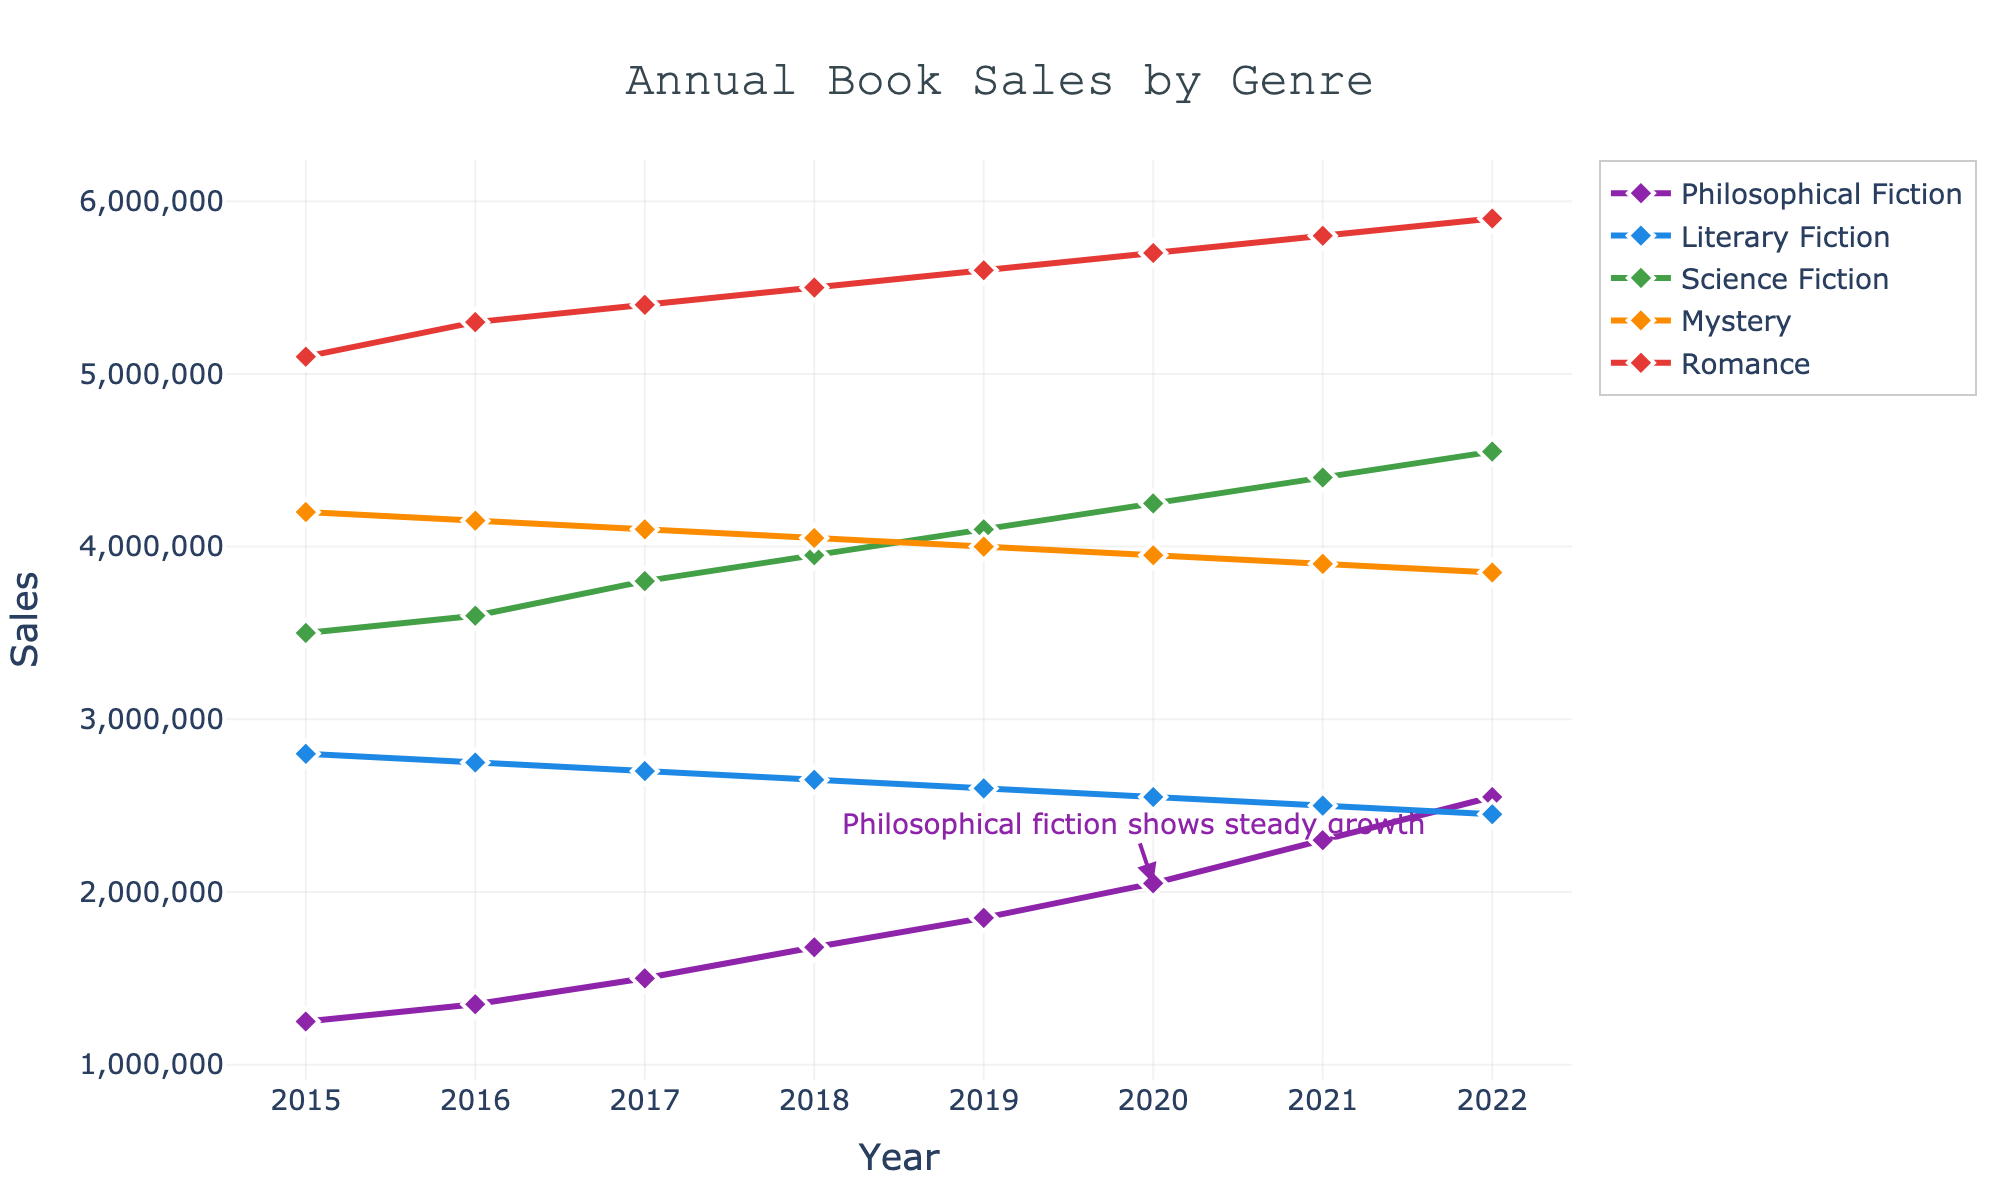What is the general trend in sales for Philosophical Fiction from 2015 to 2022? The sales for Philosophical Fiction steadily increase from 1,250,000 in 2015 to 2,550,000 in 2022. This indicates a consistent upward trend in sales over the years.
Answer: Increasing Which genre had the highest sales in 2022? By comparing the sales values for all genres in 2022, Romance stands out with the highest sales at 5,900,000.
Answer: Romance How has the sales trend for Literary Fiction changed over the years? From 2015 to 2022, sales for Literary Fiction have gradually declined from 2,800,000 to 2,450,000, showing a downward trend.
Answer: Declining What's the difference in sales between Romance and Mystery genres in 2019? In 2019, the sales for Romance were 5,600,000 while for Mystery, it was 4,000,000. The difference is 5,600,000 - 4,000,000 = 1,600,000.
Answer: 1,600,000 In which year did Science Fiction surpass the 4,000,000 sales mark? By examining the sales data for Science Fiction, it is evident that 2019 is the first year when sales surpass 4,000,000, reaching exactly 4,100,000.
Answer: 2019 Compare the sales trend between Philosophical Fiction and Science Fiction from 2015 to 2018. From 2015 to 2018, Philosophical Fiction sales steadily increase from 1,250,000 to 1,680,000. Science Fiction, on the other hand, also shows an upward trend from 3,500,000 to 3,950,000. Both genres show consistent growth.
Answer: Both increasing What is the average annual sales for Mystery from 2015 to 2022? Summing the sales for Mystery from 2015 to 2022 gives 4,200,000 + 4,150,000 + 4,100,000 + 4,050,000 + 4,000,000 + 3,950,000 + 3,900,000 + 3,850,000 = 32,200,000. Dividing by 8 years, the average is 32,200,000 / 8 = 4,025,000.
Answer: 4,025,000 What observation can you make about the annotation "Philosophical fiction shows steady growth"? The annotation highlights a point in 2020 when Philosophical Fiction sales were 2,050,000, emphasizing the consistent yearly increase in sales from 2015 to 2022.
Answer: Steady growth How did the sales of Romance compare to Philosophical Fiction in 2017? In 2017, Romance had sales of 5,400,000 while Philosophical Fiction had 1,500,000. Romance outsold Philosophical Fiction by a significant margin.
Answer: Romance much higher 